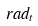Convert formula to latex. <formula><loc_0><loc_0><loc_500><loc_500>r a d _ { t }</formula> 